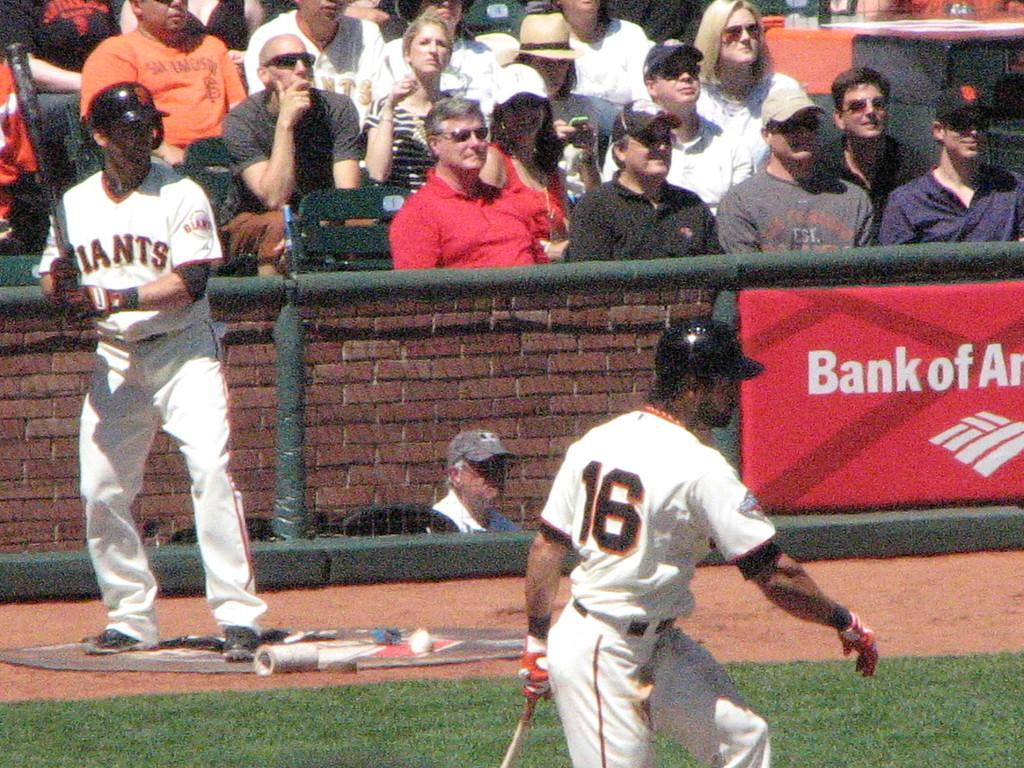<image>
Offer a succinct explanation of the picture presented. Fans watching a game of baseball featuring the Giants. 